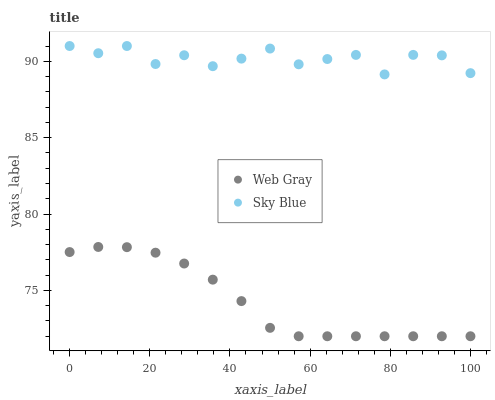Does Web Gray have the minimum area under the curve?
Answer yes or no. Yes. Does Sky Blue have the maximum area under the curve?
Answer yes or no. Yes. Does Web Gray have the maximum area under the curve?
Answer yes or no. No. Is Web Gray the smoothest?
Answer yes or no. Yes. Is Sky Blue the roughest?
Answer yes or no. Yes. Is Web Gray the roughest?
Answer yes or no. No. Does Web Gray have the lowest value?
Answer yes or no. Yes. Does Sky Blue have the highest value?
Answer yes or no. Yes. Does Web Gray have the highest value?
Answer yes or no. No. Is Web Gray less than Sky Blue?
Answer yes or no. Yes. Is Sky Blue greater than Web Gray?
Answer yes or no. Yes. Does Web Gray intersect Sky Blue?
Answer yes or no. No. 